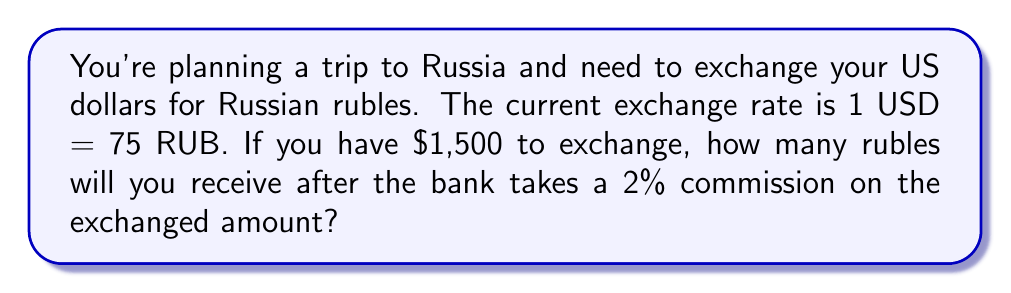Give your solution to this math problem. Let's break this down step-by-step:

1) First, calculate the amount of rubles you would receive without commission:
   $1,500 \times 75 = 112,500$ RUB

2) Now, calculate the 2% commission:
   $112,500 \times 0.02 = 2,250$ RUB

3) Subtract the commission from the total:
   $112,500 - 2,250 = 110,250$ RUB

To verify, we can use the following formula:

$$\text{Final Amount} = \text{Initial Amount} \times \text{Exchange Rate} \times (1 - \text{Commission Rate})$$

$$\text{Final Amount} = 1500 \times 75 \times (1 - 0.02) = 1500 \times 75 \times 0.98 = 110,250 \text{ RUB}$$

This confirms our step-by-step calculation.
Answer: 110,250 RUB 